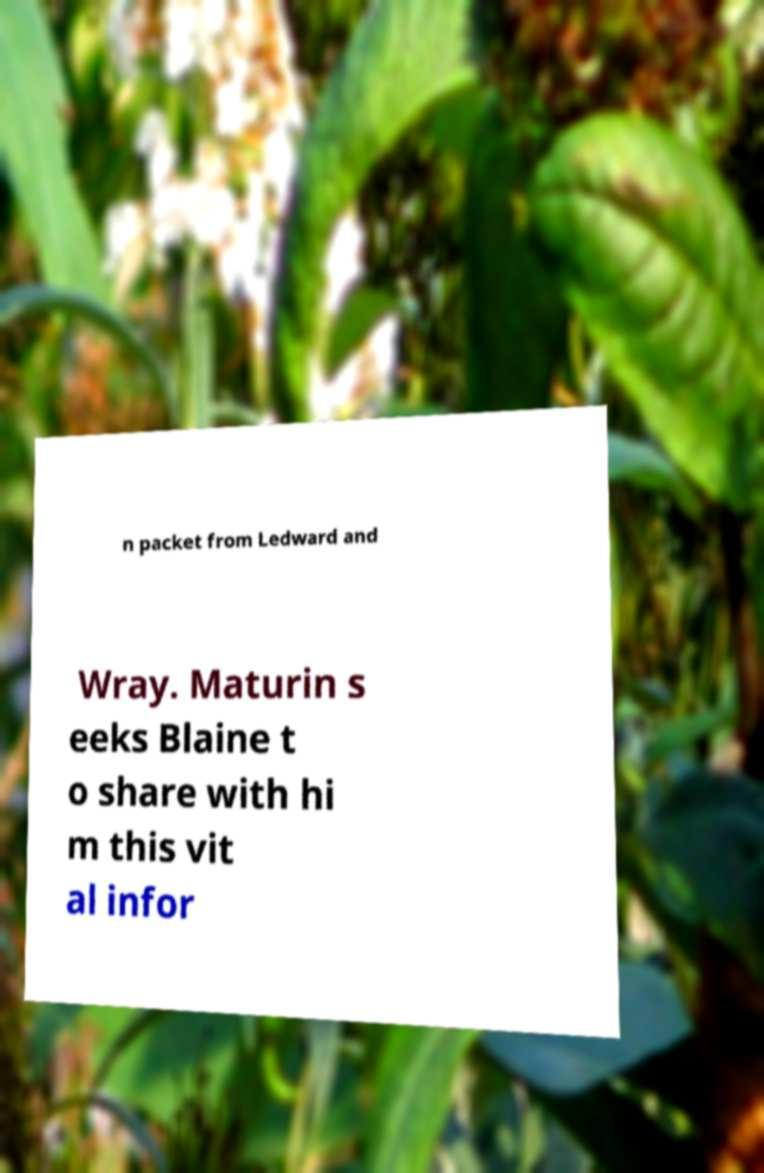For documentation purposes, I need the text within this image transcribed. Could you provide that? n packet from Ledward and Wray. Maturin s eeks Blaine t o share with hi m this vit al infor 